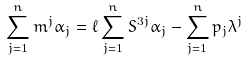Convert formula to latex. <formula><loc_0><loc_0><loc_500><loc_500>\sum _ { j = 1 } ^ { n } m ^ { j } \alpha _ { j } = \ell \sum _ { j = 1 } ^ { n } S ^ { 3 j } \alpha _ { j } - \sum _ { j = 1 } ^ { n } p _ { j } \lambda ^ { j }</formula> 